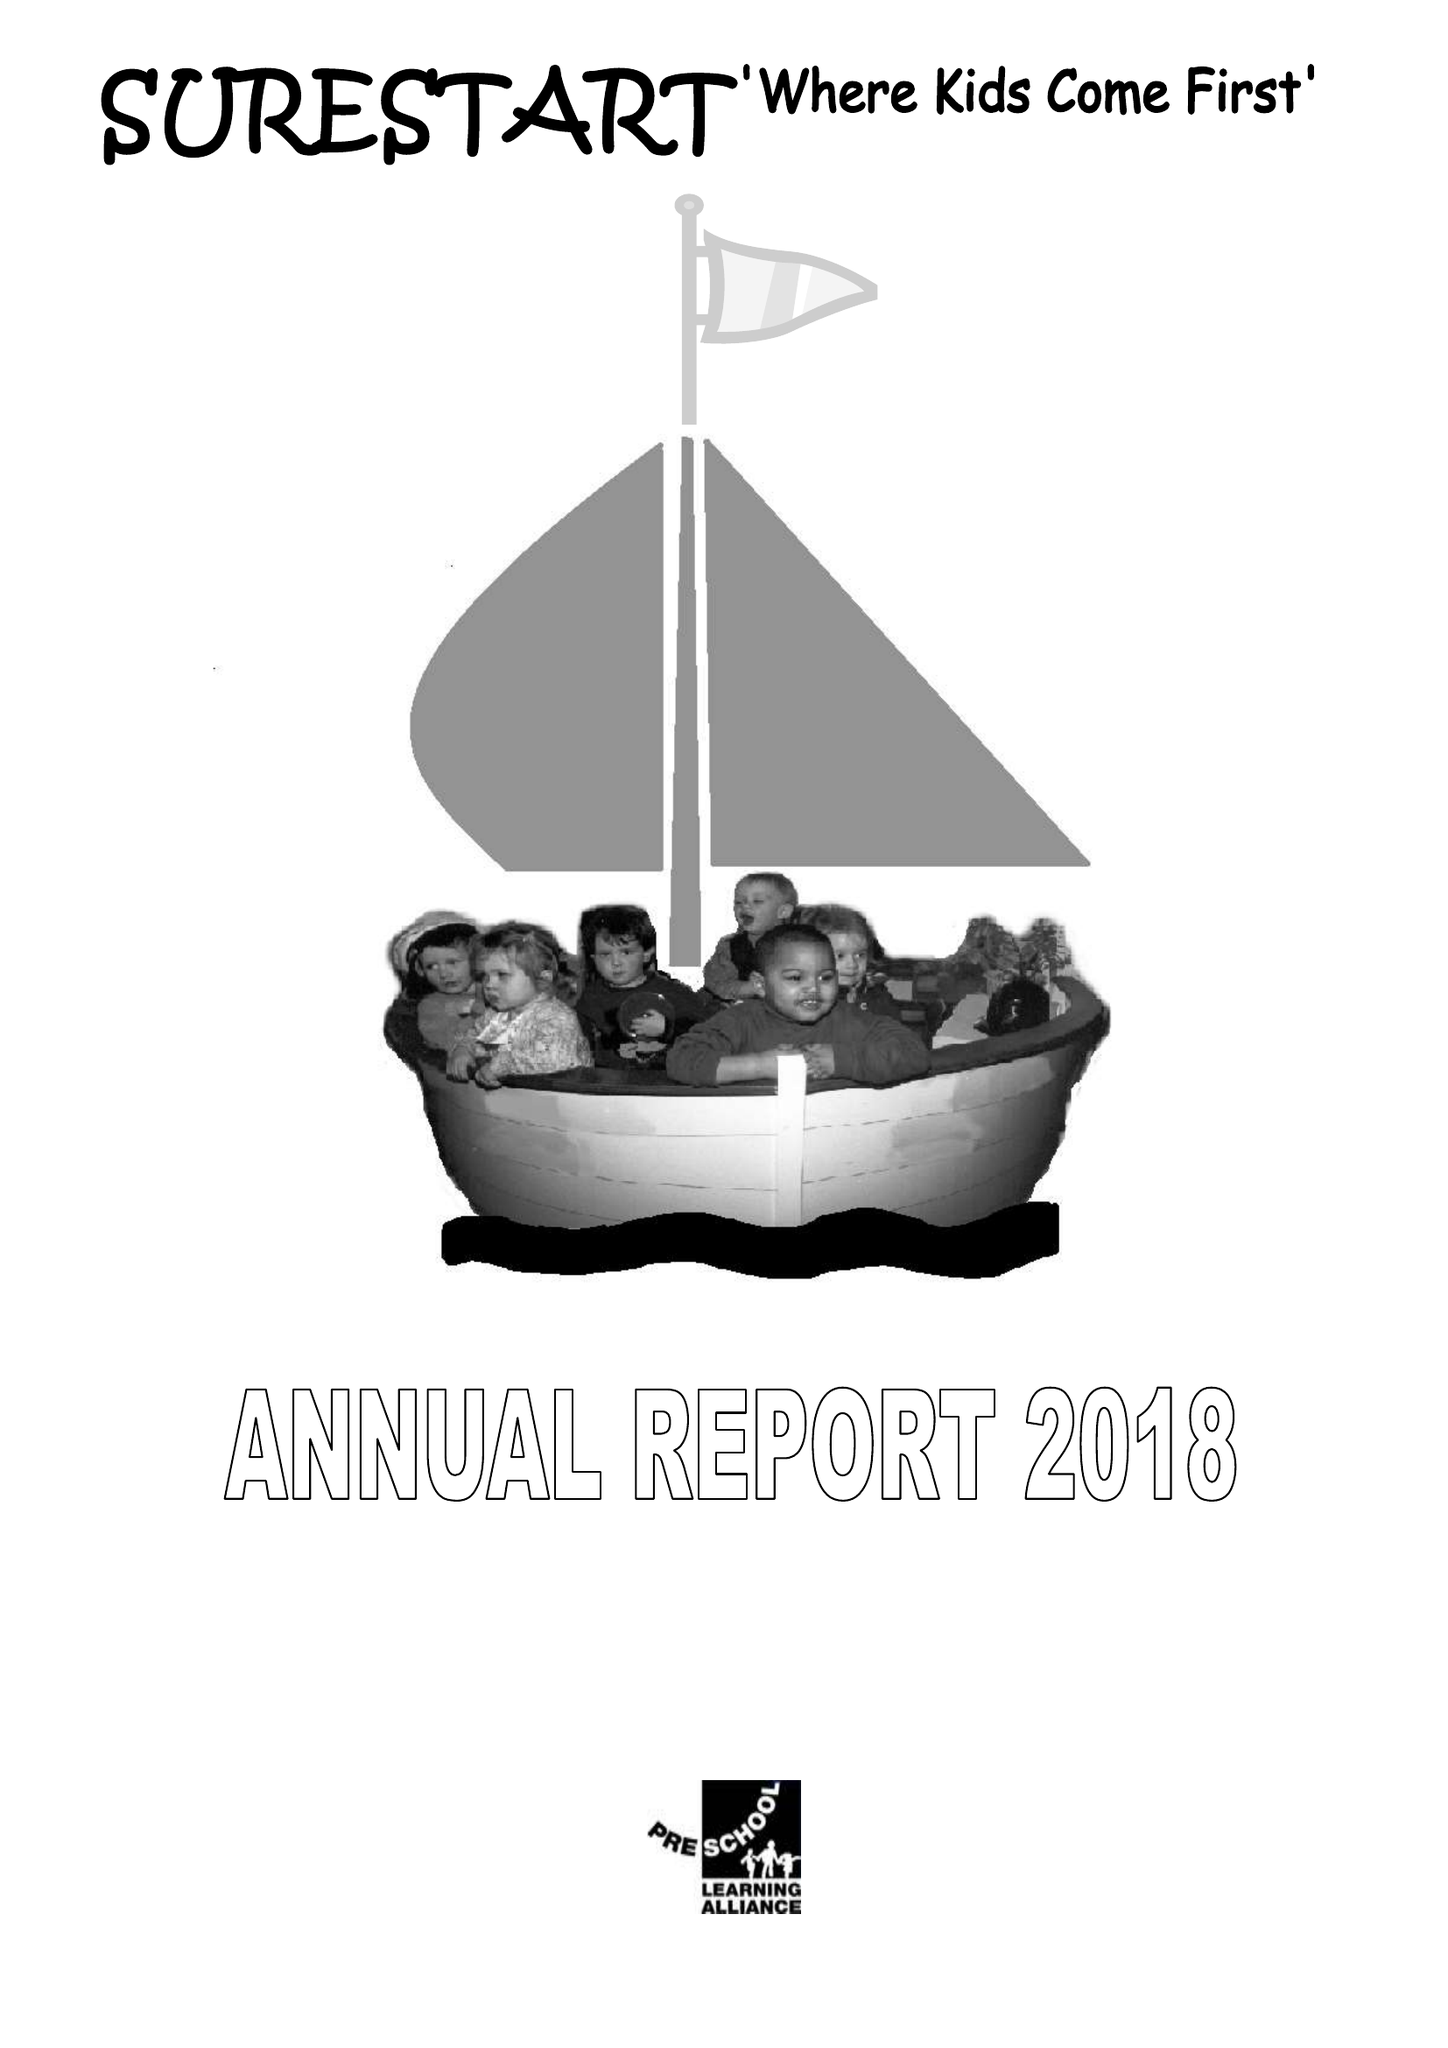What is the value for the address__street_line?
Answer the question using a single word or phrase. None 